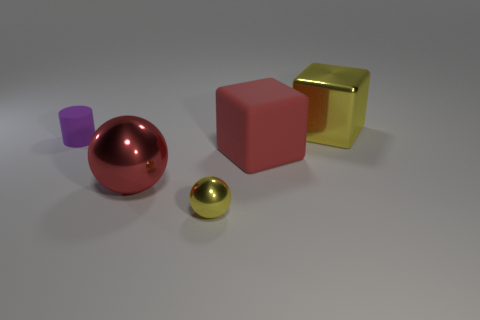Is the color of the large matte thing the same as the big sphere?
Make the answer very short. Yes. There is a rubber thing to the left of the yellow metal thing that is left of the red rubber thing; what is its size?
Provide a short and direct response. Small. The big yellow shiny object that is behind the matte thing that is to the right of the yellow metallic object that is in front of the red rubber block is what shape?
Make the answer very short. Cube. What is the size of the yellow object that is made of the same material as the yellow cube?
Your response must be concise. Small. Are there more small yellow metallic objects than brown objects?
Offer a terse response. Yes. What material is the red object that is the same size as the red metal ball?
Your response must be concise. Rubber. There is a yellow shiny object in front of the red ball; does it have the same size as the small purple matte cylinder?
Make the answer very short. Yes. What number of cylinders are purple rubber objects or big red objects?
Your answer should be very brief. 1. What is the block in front of the purple rubber object made of?
Your answer should be compact. Rubber. Is the number of tiny green things less than the number of big matte objects?
Offer a terse response. Yes. 